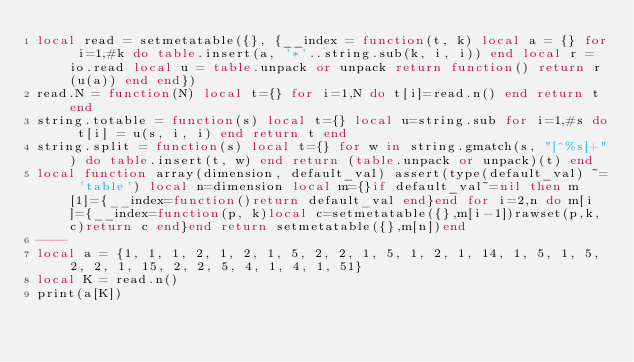<code> <loc_0><loc_0><loc_500><loc_500><_Lua_>local read = setmetatable({}, {__index = function(t, k) local a = {} for i=1,#k do table.insert(a, '*'..string.sub(k, i, i)) end local r = io.read local u = table.unpack or unpack return function() return r(u(a)) end end})
read.N = function(N) local t={} for i=1,N do t[i]=read.n() end return t end
string.totable = function(s) local t={} local u=string.sub for i=1,#s do t[i] = u(s, i, i) end return t end
string.split = function(s) local t={} for w in string.gmatch(s, "[^%s]+") do table.insert(t, w) end return (table.unpack or unpack)(t) end
local function array(dimension, default_val) assert(type(default_val) ~= 'table') local n=dimension local m={}if default_val~=nil then m[1]={__index=function()return default_val end}end for i=2,n do m[i]={__index=function(p, k)local c=setmetatable({},m[i-1])rawset(p,k,c)return c end}end return setmetatable({},m[n])end
----
local a = {1, 1, 1, 2, 1, 2, 1, 5, 2, 2, 1, 5, 1, 2, 1, 14, 1, 5, 1, 5, 2, 2, 1, 15, 2, 2, 5, 4, 1, 4, 1, 51}
local K = read.n()
print(a[K])</code> 